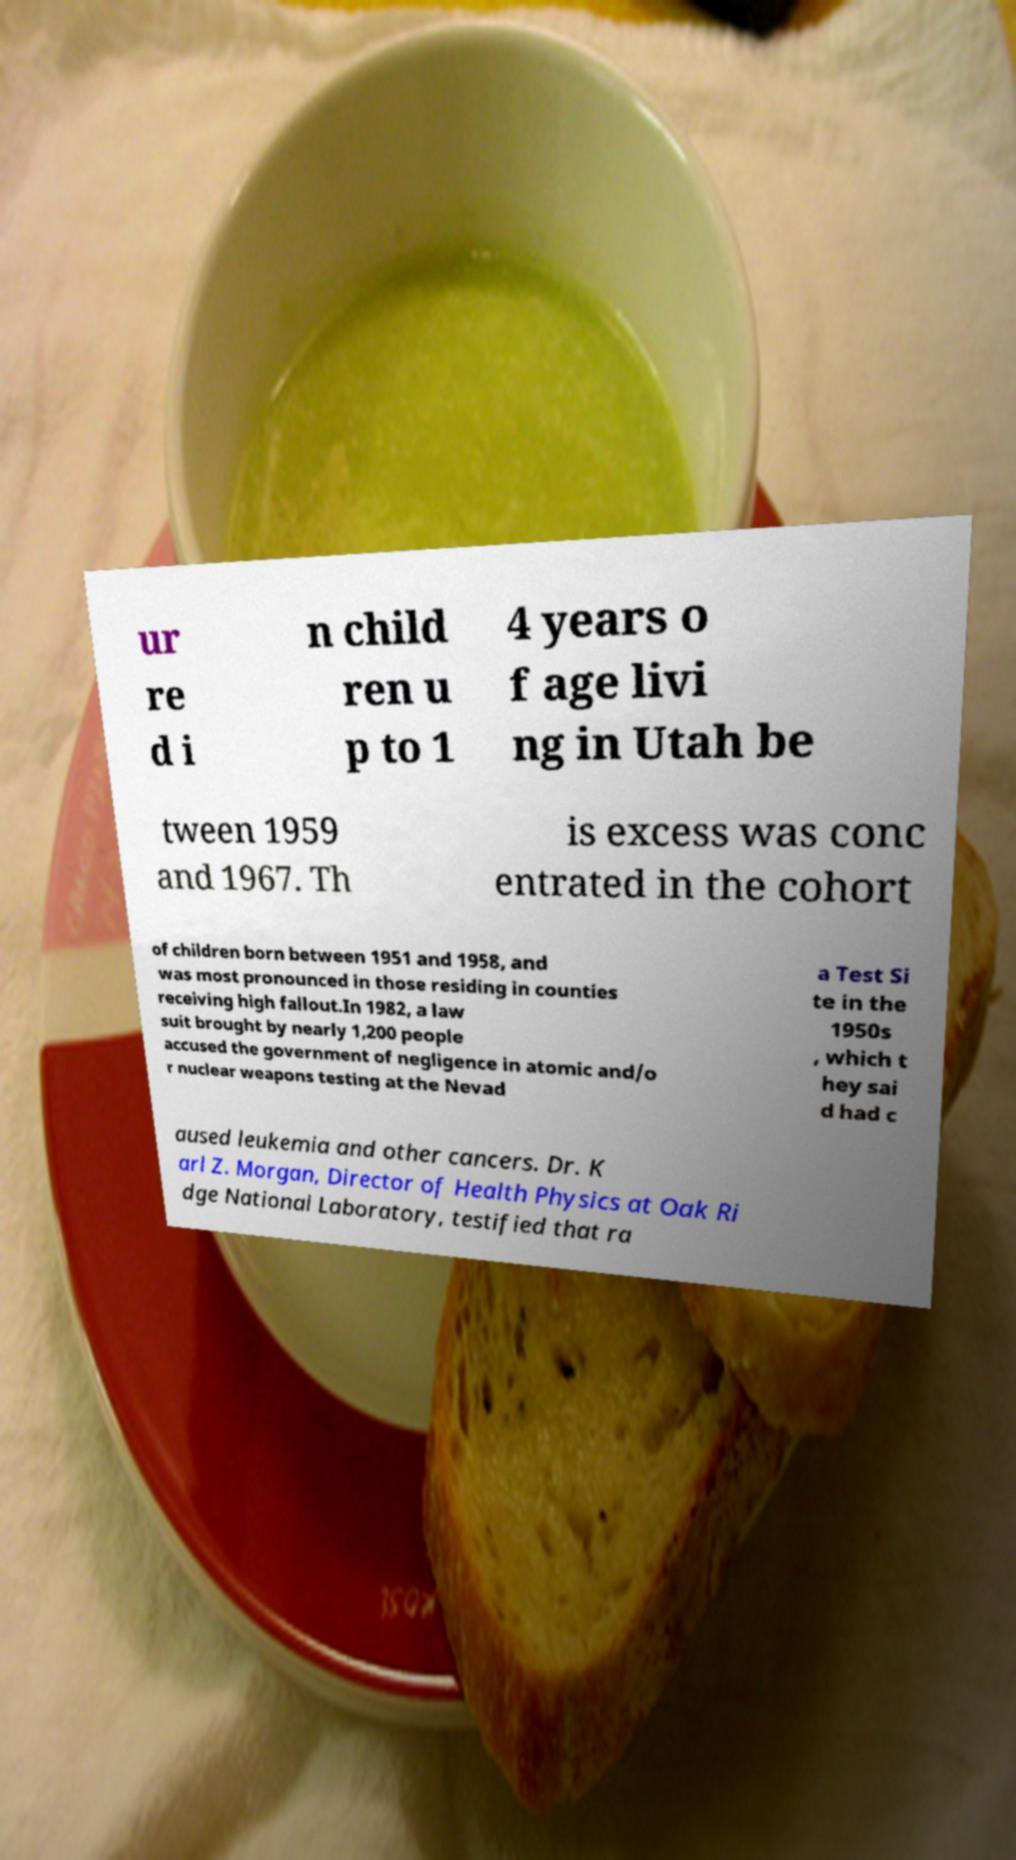For documentation purposes, I need the text within this image transcribed. Could you provide that? ur re d i n child ren u p to 1 4 years o f age livi ng in Utah be tween 1959 and 1967. Th is excess was conc entrated in the cohort of children born between 1951 and 1958, and was most pronounced in those residing in counties receiving high fallout.In 1982, a law suit brought by nearly 1,200 people accused the government of negligence in atomic and/o r nuclear weapons testing at the Nevad a Test Si te in the 1950s , which t hey sai d had c aused leukemia and other cancers. Dr. K arl Z. Morgan, Director of Health Physics at Oak Ri dge National Laboratory, testified that ra 